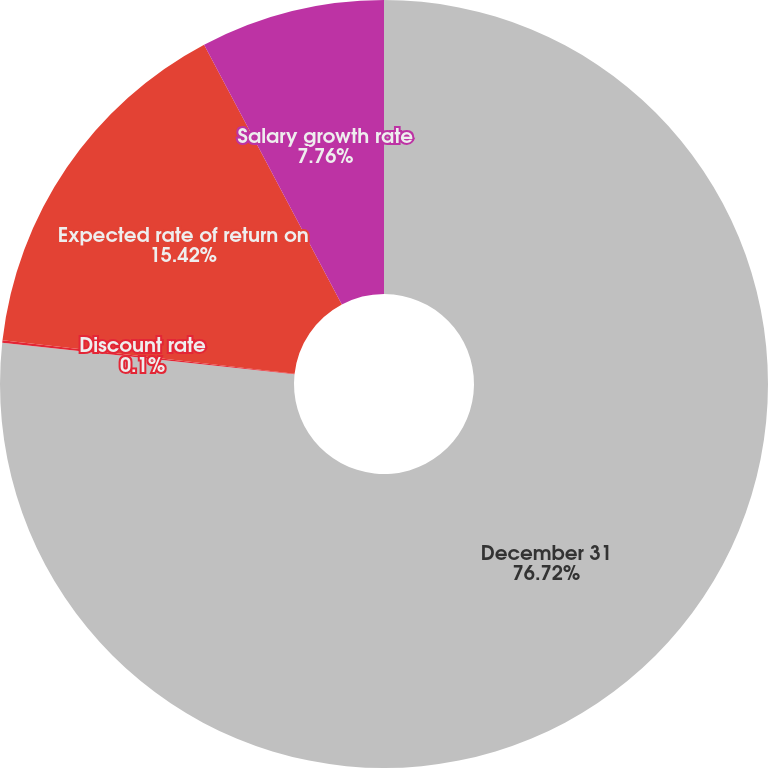Convert chart. <chart><loc_0><loc_0><loc_500><loc_500><pie_chart><fcel>December 31<fcel>Discount rate<fcel>Expected rate of return on<fcel>Salary growth rate<nl><fcel>76.71%<fcel>0.1%<fcel>15.42%<fcel>7.76%<nl></chart> 